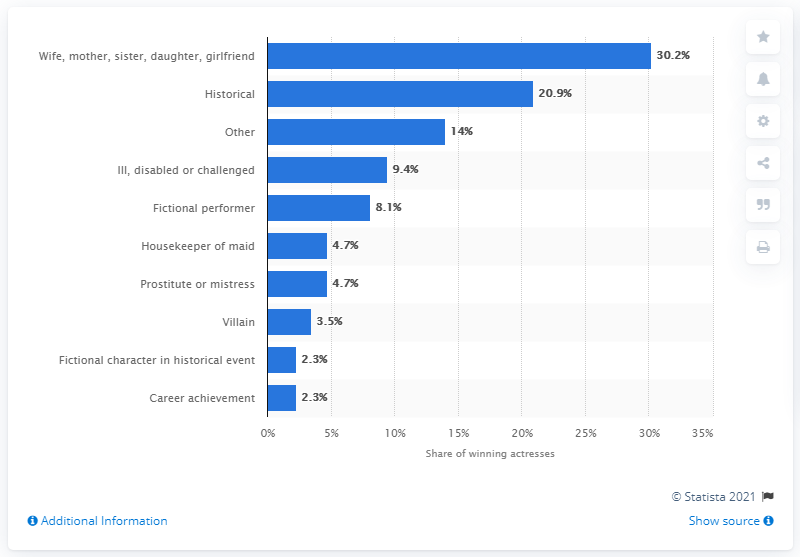Point out several critical features in this image. The ratio of fictional character to career achievement is 3.52173913... Nine types have been considered. 